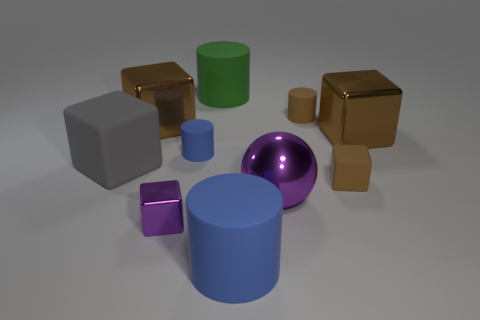Subtract all brown cubes. How many were subtracted if there are1brown cubes left? 2 Subtract all brown balls. How many brown blocks are left? 3 Subtract 1 cylinders. How many cylinders are left? 3 Subtract all gray blocks. How many blocks are left? 4 Subtract all gray cubes. How many cubes are left? 4 Subtract all cyan cubes. Subtract all gray spheres. How many cubes are left? 5 Subtract all cylinders. How many objects are left? 6 Subtract all tiny blue matte cylinders. Subtract all shiny things. How many objects are left? 5 Add 2 big metal spheres. How many big metal spheres are left? 3 Add 7 brown metal objects. How many brown metal objects exist? 9 